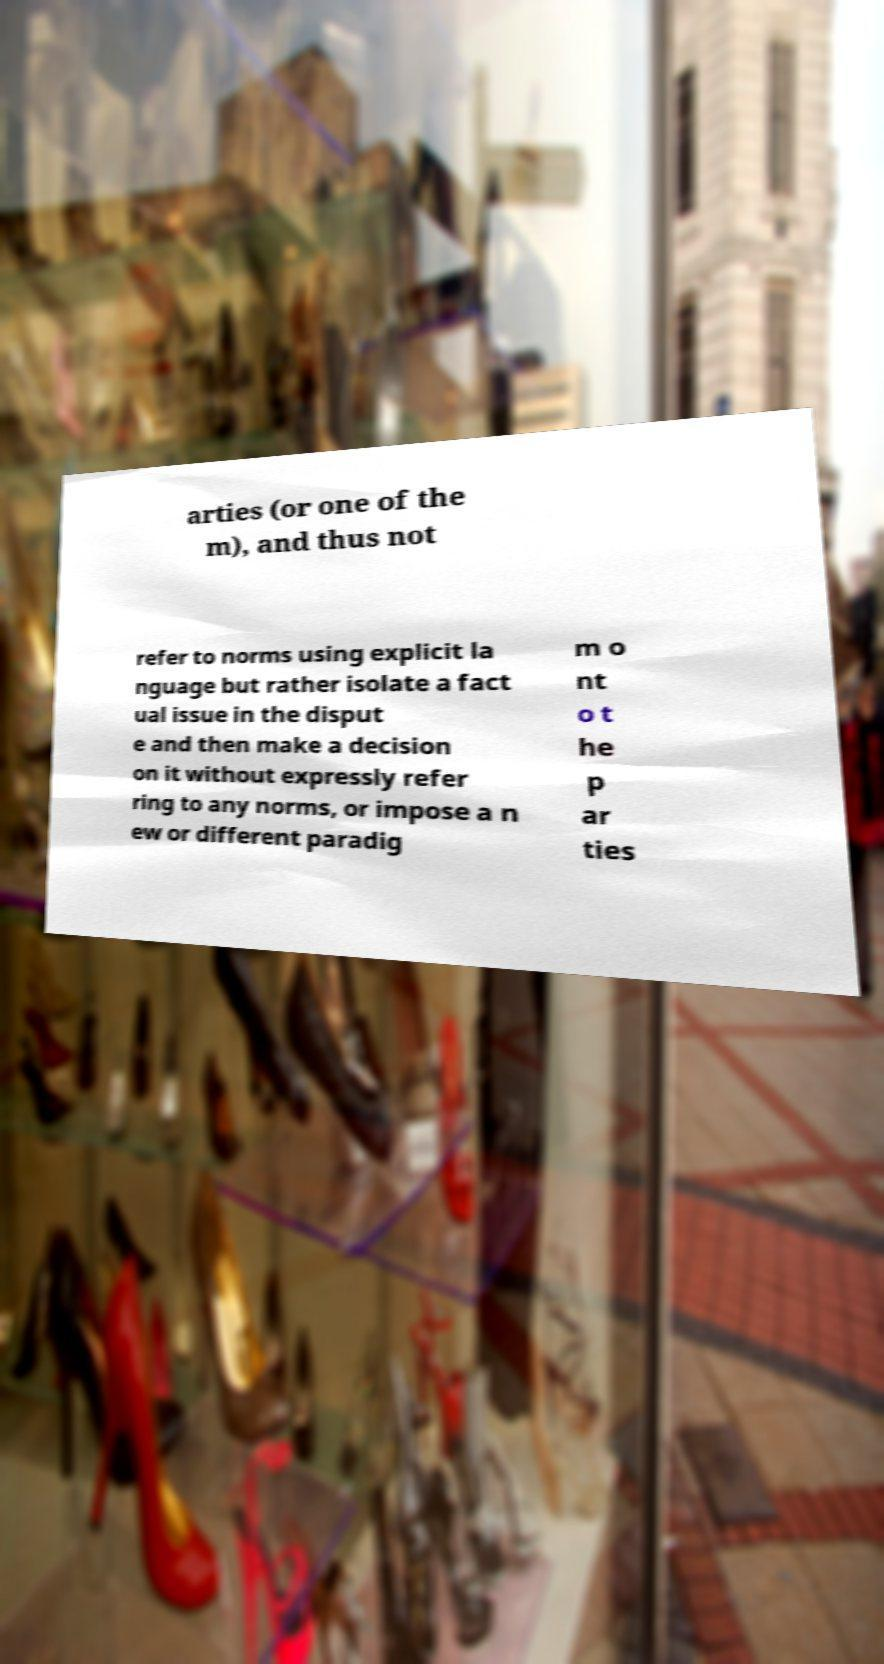Can you read and provide the text displayed in the image?This photo seems to have some interesting text. Can you extract and type it out for me? arties (or one of the m), and thus not refer to norms using explicit la nguage but rather isolate a fact ual issue in the disput e and then make a decision on it without expressly refer ring to any norms, or impose a n ew or different paradig m o nt o t he p ar ties 